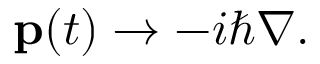Convert formula to latex. <formula><loc_0><loc_0><loc_500><loc_500>p ( t ) \to - i \hbar { \nabla } .</formula> 